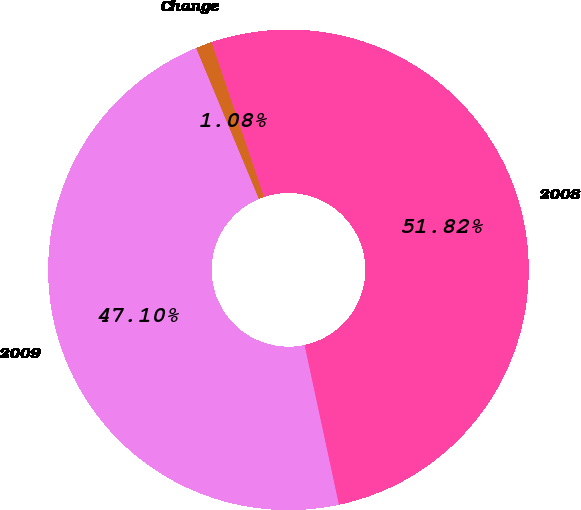Convert chart. <chart><loc_0><loc_0><loc_500><loc_500><pie_chart><fcel>2009<fcel>2008<fcel>Change<nl><fcel>47.1%<fcel>51.82%<fcel>1.08%<nl></chart> 